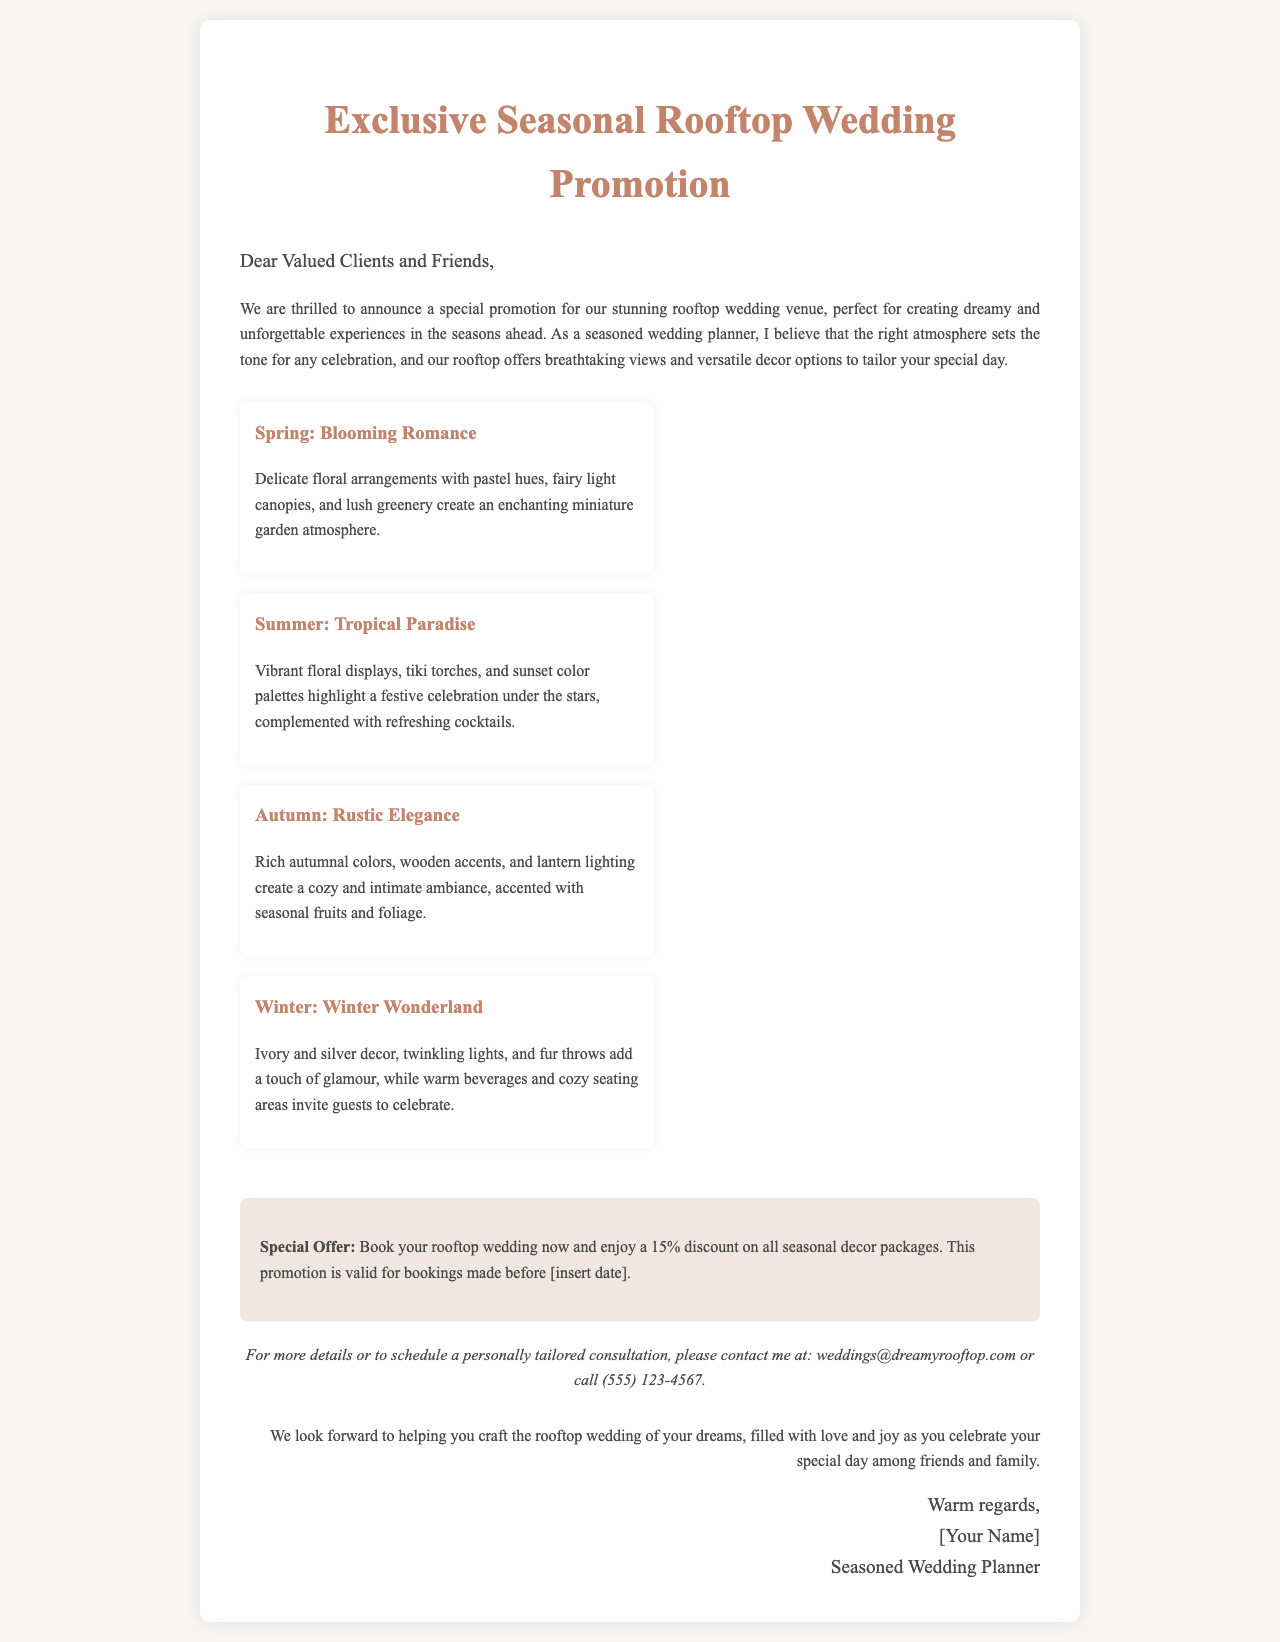What is the title of the promotion? The title of the promotion is stated at the beginning of the document.
Answer: Exclusive Seasonal Rooftop Wedding Promotion What discount is offered for bookings? The document specifies a discount percentage for bookings made during the promotion.
Answer: 15% Which season features "Blooming Romance"? The document lists seasonal themes, including "Blooming Romance".
Answer: Spring What is the contact email provided? The contact email is presented in the contact section for inquiries.
Answer: weddings@dreamyrooftop.com What types of decor are suggested for Winter? The document describes specific decor elements for the Winter season theme.
Answer: Ivory and silver decor, twinkling lights, and fur throws What ambiance is created during Autumn? The description of seasonal themes offers insights into the type of ambiance for Autumn.
Answer: Cozy and intimate ambiance When should the booking be made to take advantage of the promotion? The document indicates a timeline regarding booking in relation to the promotion validity.
Answer: Before [insert date] Which season highlights "Tropical Paradise"? The seasonal theme for Summer is highlighted in the document.
Answer: Summer 